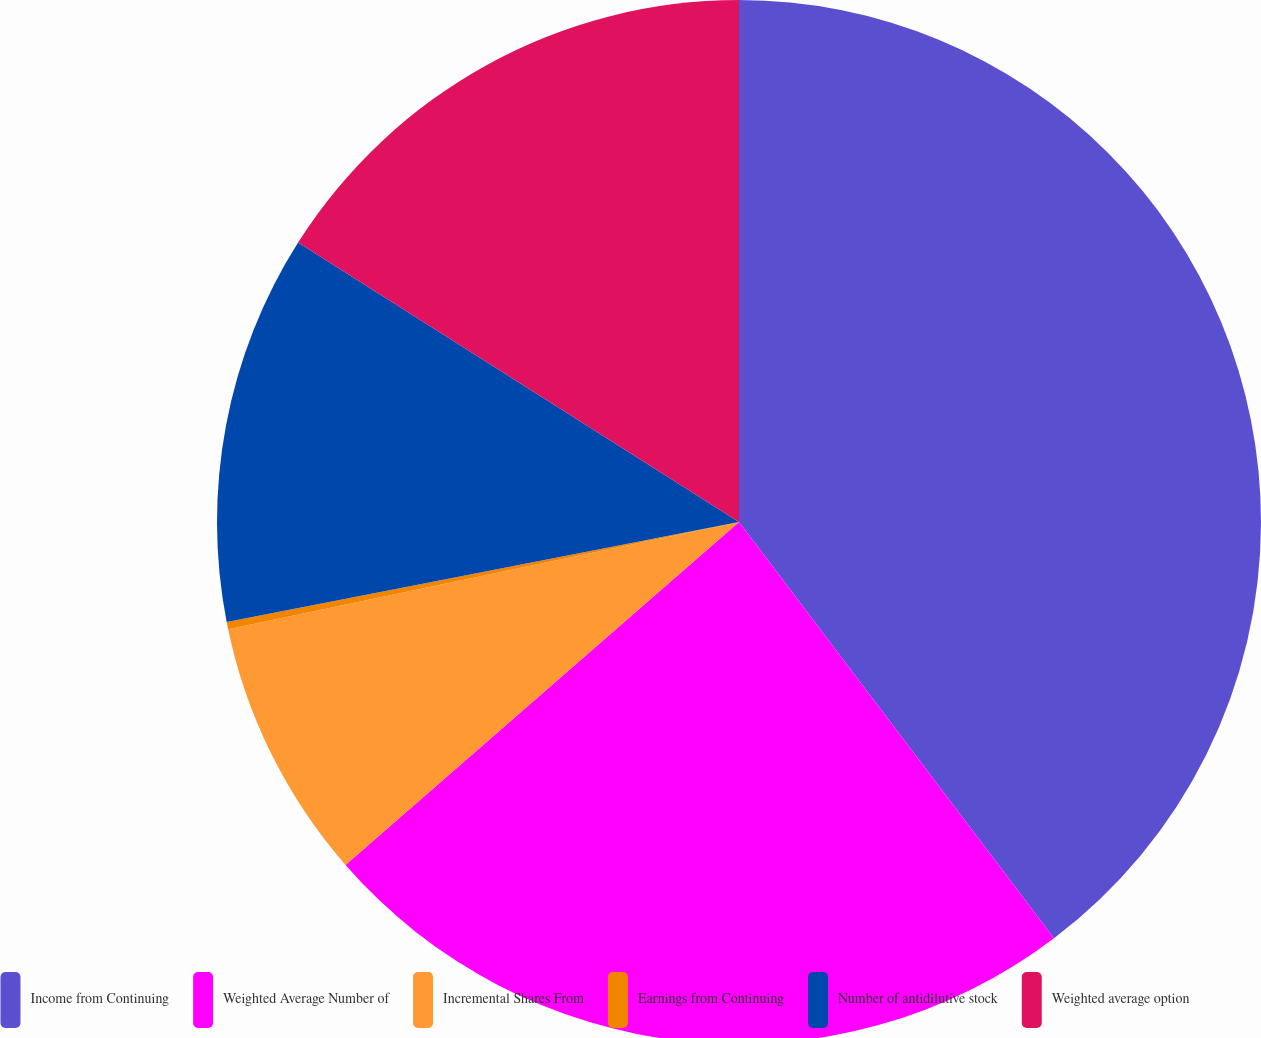Convert chart. <chart><loc_0><loc_0><loc_500><loc_500><pie_chart><fcel>Income from Continuing<fcel>Weighted Average Number of<fcel>Incremental Shares From<fcel>Earnings from Continuing<fcel>Number of antidilutive stock<fcel>Weighted average option<nl><fcel>39.69%<fcel>23.9%<fcel>8.12%<fcel>0.22%<fcel>12.06%<fcel>16.01%<nl></chart> 